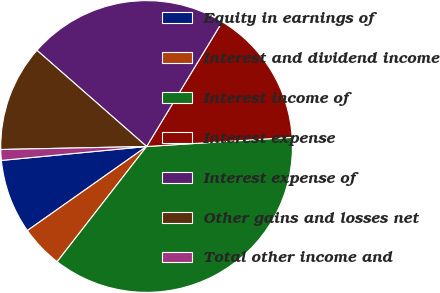<chart> <loc_0><loc_0><loc_500><loc_500><pie_chart><fcel>Equity in earnings of<fcel>Interest and dividend income<fcel>Interest income of<fcel>Interest expense<fcel>Interest expense of<fcel>Other gains and losses net<fcel>Total other income and<nl><fcel>8.25%<fcel>4.72%<fcel>36.51%<fcel>15.32%<fcel>22.22%<fcel>11.79%<fcel>1.19%<nl></chart> 